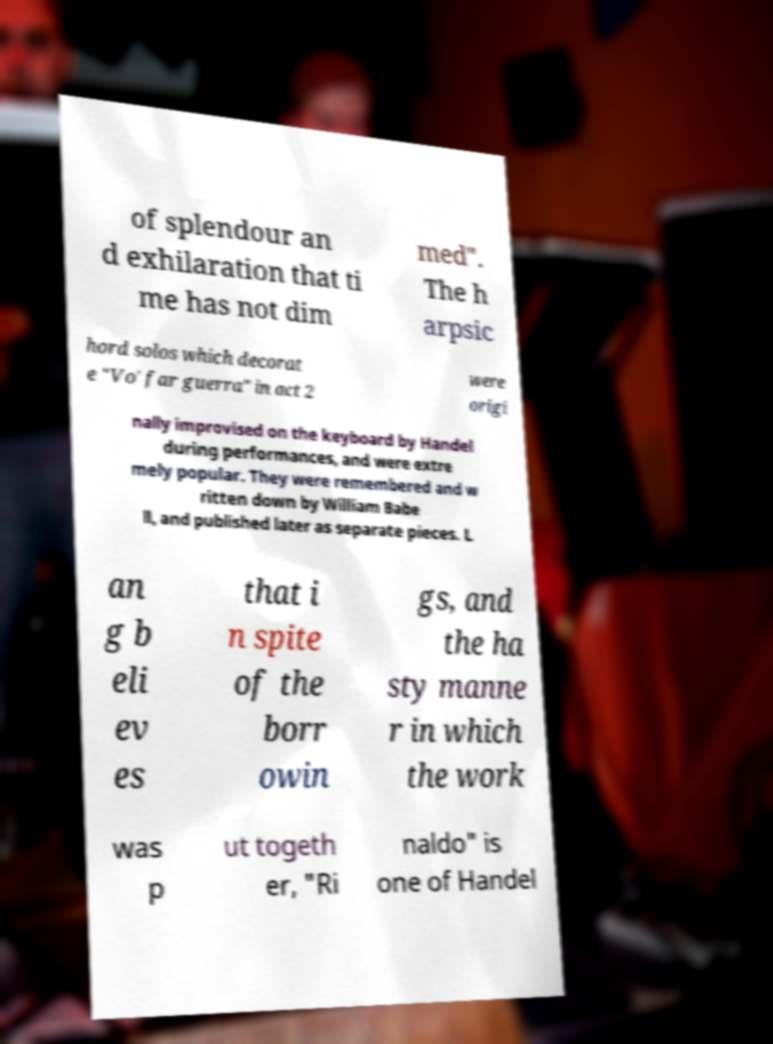Could you extract and type out the text from this image? of splendour an d exhilaration that ti me has not dim med". The h arpsic hord solos which decorat e "Vo' far guerra" in act 2 were origi nally improvised on the keyboard by Handel during performances, and were extre mely popular. They were remembered and w ritten down by William Babe ll, and published later as separate pieces. L an g b eli ev es that i n spite of the borr owin gs, and the ha sty manne r in which the work was p ut togeth er, "Ri naldo" is one of Handel 